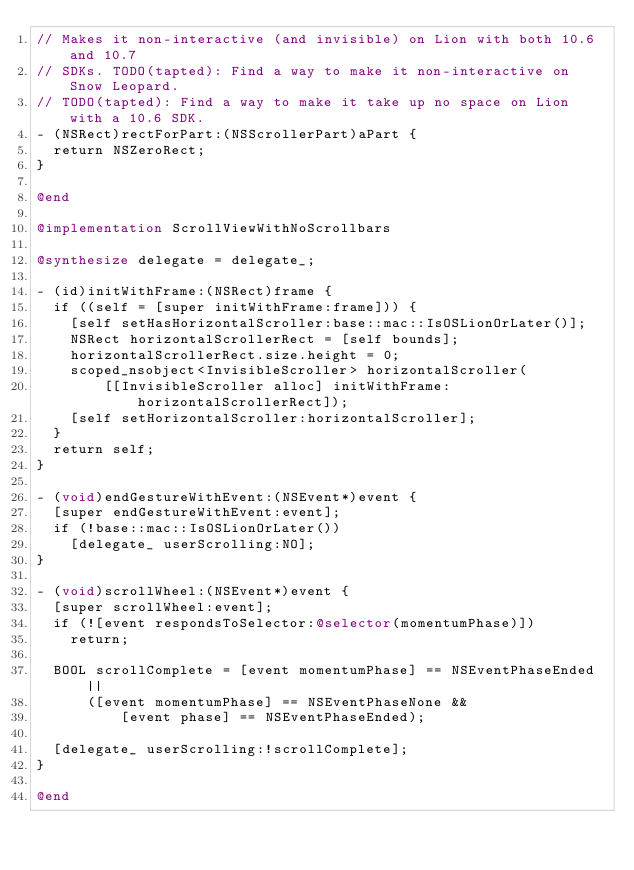<code> <loc_0><loc_0><loc_500><loc_500><_ObjectiveC_>// Makes it non-interactive (and invisible) on Lion with both 10.6 and 10.7
// SDKs. TODO(tapted): Find a way to make it non-interactive on Snow Leopard.
// TODO(tapted): Find a way to make it take up no space on Lion with a 10.6 SDK.
- (NSRect)rectForPart:(NSScrollerPart)aPart {
  return NSZeroRect;
}

@end

@implementation ScrollViewWithNoScrollbars

@synthesize delegate = delegate_;

- (id)initWithFrame:(NSRect)frame {
  if ((self = [super initWithFrame:frame])) {
    [self setHasHorizontalScroller:base::mac::IsOSLionOrLater()];
    NSRect horizontalScrollerRect = [self bounds];
    horizontalScrollerRect.size.height = 0;
    scoped_nsobject<InvisibleScroller> horizontalScroller(
        [[InvisibleScroller alloc] initWithFrame:horizontalScrollerRect]);
    [self setHorizontalScroller:horizontalScroller];
  }
  return self;
}

- (void)endGestureWithEvent:(NSEvent*)event {
  [super endGestureWithEvent:event];
  if (!base::mac::IsOSLionOrLater())
    [delegate_ userScrolling:NO];
}

- (void)scrollWheel:(NSEvent*)event {
  [super scrollWheel:event];
  if (![event respondsToSelector:@selector(momentumPhase)])
    return;

  BOOL scrollComplete = [event momentumPhase] == NSEventPhaseEnded ||
      ([event momentumPhase] == NSEventPhaseNone &&
          [event phase] == NSEventPhaseEnded);

  [delegate_ userScrolling:!scrollComplete];
}

@end
</code> 